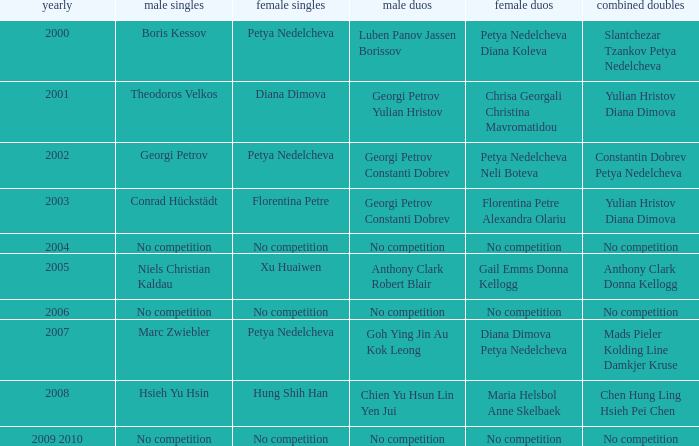During what year was conrad hückstädt the winner of the men's single competition? 2003.0. 